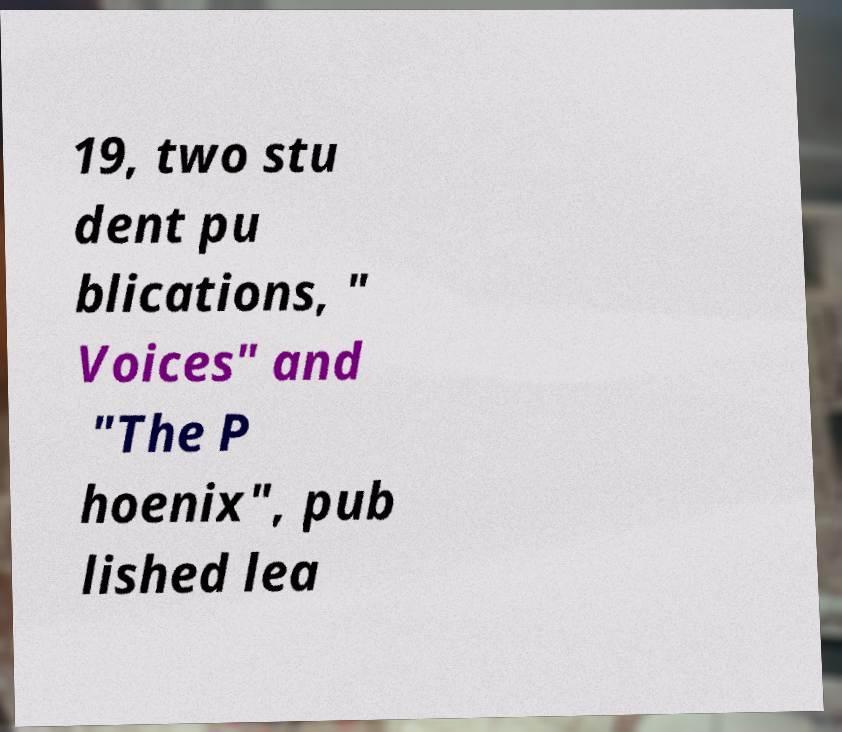What messages or text are displayed in this image? I need them in a readable, typed format. 19, two stu dent pu blications, " Voices" and "The P hoenix", pub lished lea 